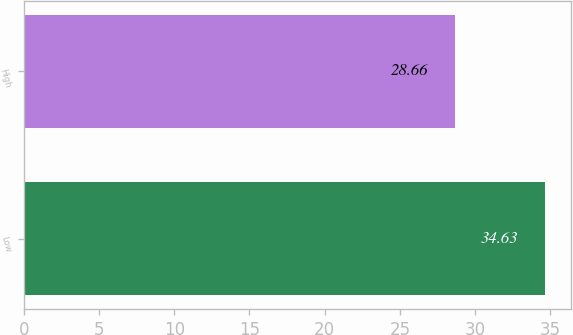Convert chart. <chart><loc_0><loc_0><loc_500><loc_500><bar_chart><fcel>Low<fcel>High<nl><fcel>34.63<fcel>28.66<nl></chart> 